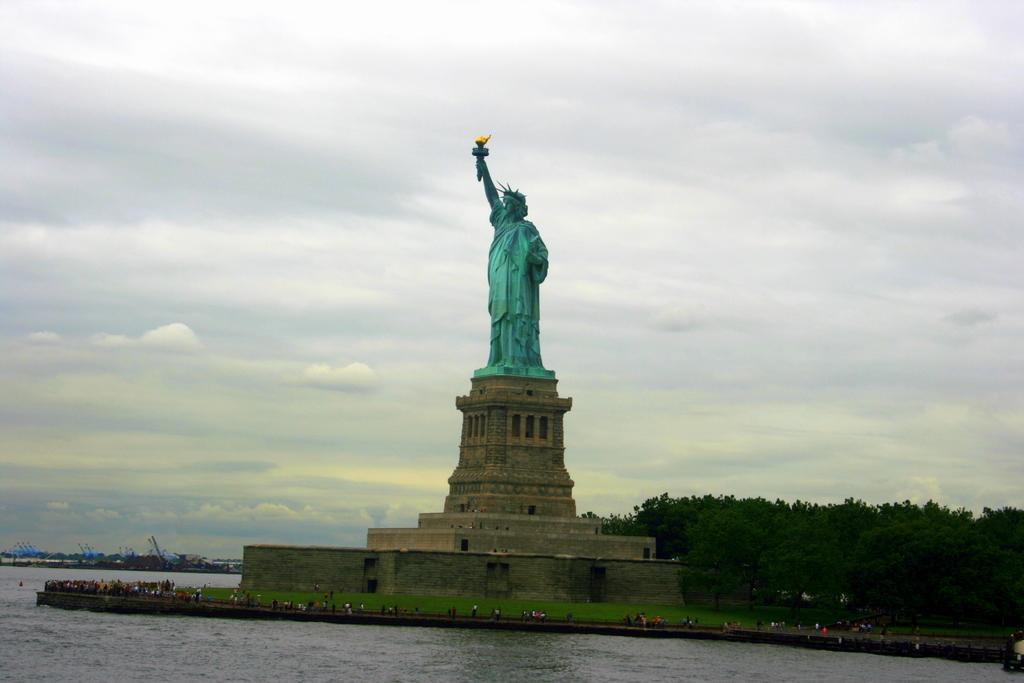Can you describe this image briefly? In the middle of this image, there is a statue on a platform. Around this platform, there are persons and grass on the ground. Around this ground, there is water. In the background, there are trees and there are clouds in the sky. 